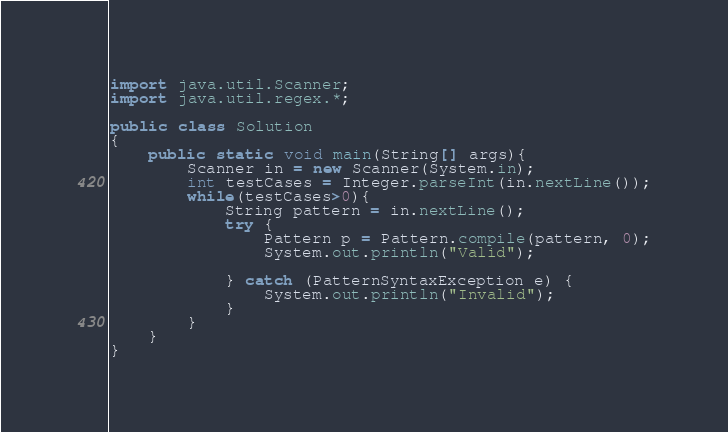Convert code to text. <code><loc_0><loc_0><loc_500><loc_500><_Java_>import java.util.Scanner;
import java.util.regex.*;

public class Solution
{
	public static void main(String[] args){
		Scanner in = new Scanner(System.in);
		int testCases = Integer.parseInt(in.nextLine());
		while(testCases>0){
			String pattern = in.nextLine();
          	try {
                Pattern p = Pattern.compile(pattern, 0);
                System.out.println("Valid");
                
            } catch (PatternSyntaxException e) {
                System.out.println("Invalid");
            }
		}
	}
}




</code> 